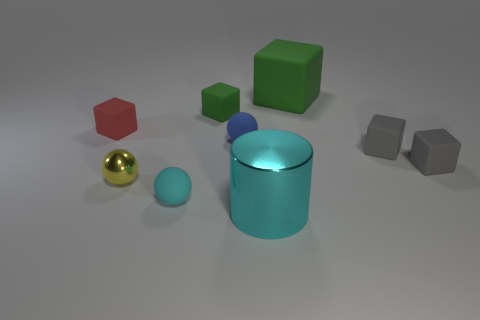Subtract all large matte cubes. How many cubes are left? 4 Subtract all cyan balls. How many balls are left? 2 Subtract all cyan balls. How many gray blocks are left? 2 Subtract 3 cubes. How many cubes are left? 2 Subtract all blue balls. Subtract all rubber blocks. How many objects are left? 3 Add 7 rubber spheres. How many rubber spheres are left? 9 Add 3 big rubber objects. How many big rubber objects exist? 4 Subtract 2 gray cubes. How many objects are left? 7 Subtract all cylinders. How many objects are left? 8 Subtract all red blocks. Subtract all yellow cylinders. How many blocks are left? 4 